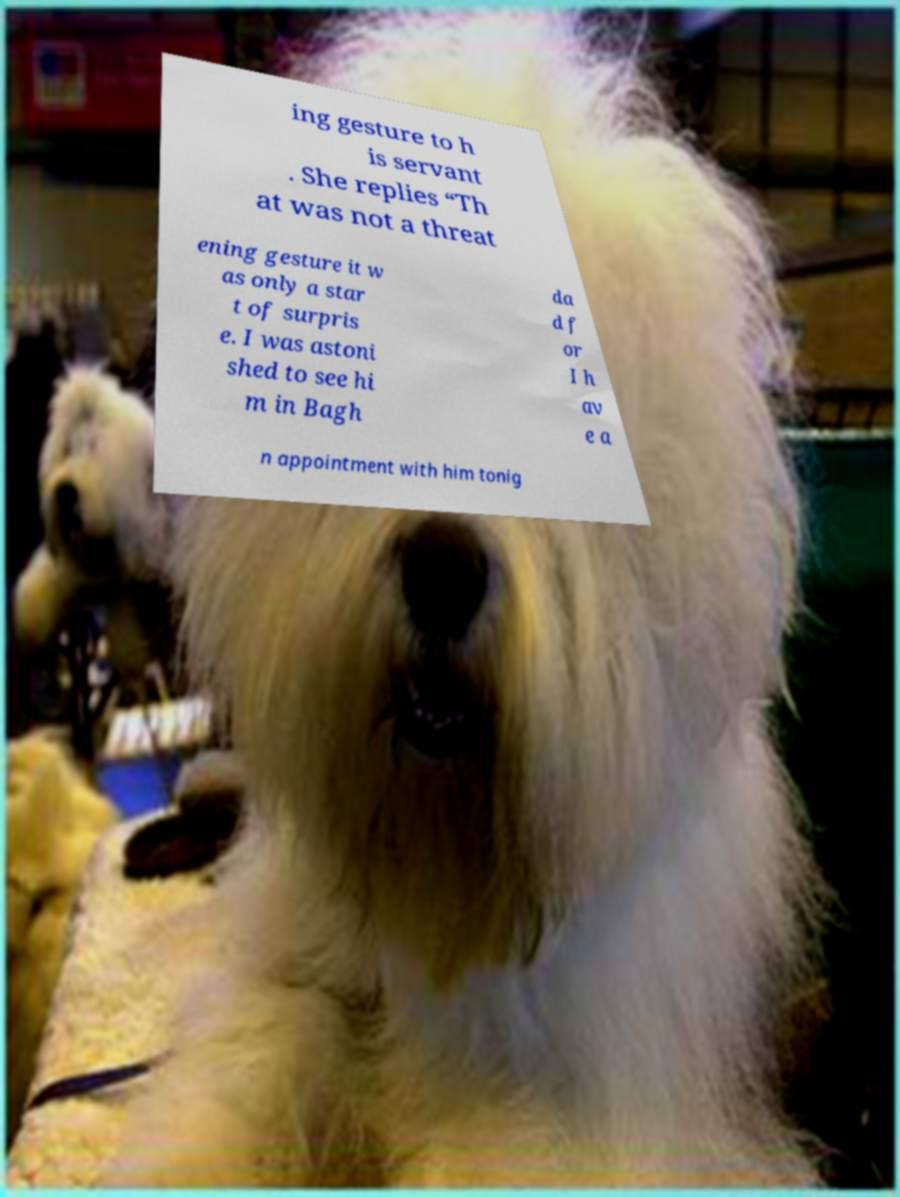For documentation purposes, I need the text within this image transcribed. Could you provide that? ing gesture to h is servant . She replies “Th at was not a threat ening gesture it w as only a star t of surpris e. I was astoni shed to see hi m in Bagh da d f or I h av e a n appointment with him tonig 